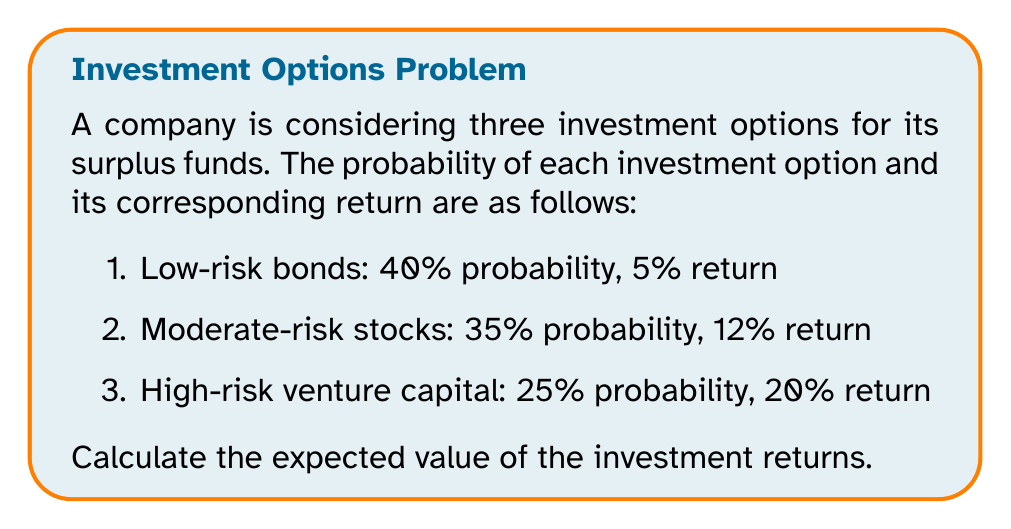Teach me how to tackle this problem. To calculate the expected value of investment returns, we need to follow these steps:

1. Identify the random variable: In this case, it's the investment return.

2. List all possible outcomes and their probabilities:
   - Low-risk bonds: 5% return, 0.40 probability
   - Moderate-risk stocks: 12% return, 0.35 probability
   - High-risk venture capital: 20% return, 0.25 probability

3. Calculate the expected value using the formula:

   $$ E(X) = \sum_{i=1}^{n} x_i \cdot p(x_i) $$

   Where:
   - $E(X)$ is the expected value
   - $x_i$ is the value of each outcome
   - $p(x_i)$ is the probability of each outcome

4. Plug in the values:

   $$ E(X) = (0.05 \cdot 0.40) + (0.12 \cdot 0.35) + (0.20 \cdot 0.25) $$

5. Calculate:
   $$ E(X) = 0.02 + 0.042 + 0.05 = 0.112 $$

6. Convert the result to a percentage:
   $$ 0.112 \cdot 100\% = 11.2\% $$

Therefore, the expected value of the investment returns is 11.2%.
Answer: The expected value of the investment returns is 11.2%. 